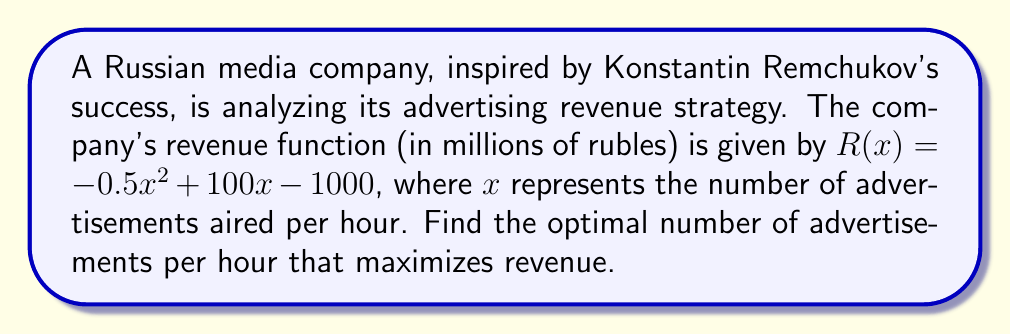Could you help me with this problem? To find the maximum revenue point, we need to follow these steps:

1) The revenue function is a quadratic equation: $R(x) = -0.5x^2 + 100x - 1000$

2) To find the maximum point, we need to find where the derivative of the function equals zero:
   
   $\frac{dR}{dx} = -x + 100$

3) Set the derivative equal to zero and solve for x:
   
   $-x + 100 = 0$
   $x = 100$

4) To confirm this is a maximum (not a minimum), check the second derivative:
   
   $\frac{d^2R}{dx^2} = -1$

   Since the second derivative is negative, this confirms we have a maximum.

5) The optimal number of advertisements per hour is 100.

6) To calculate the maximum revenue, substitute x = 100 into the original function:

   $R(100) = -0.5(100)^2 + 100(100) - 1000$
           $= -5000 + 10000 - 1000$
           $= 4000$

Therefore, the maximum revenue is 4000 million rubles, achieved by airing 100 advertisements per hour.
Answer: 100 advertisements per hour 